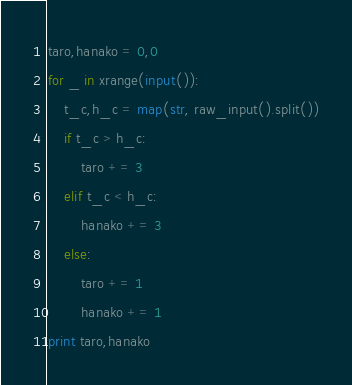Convert code to text. <code><loc_0><loc_0><loc_500><loc_500><_Python_>taro,hanako = 0,0
for _ in xrange(input()):
    t_c,h_c = map(str, raw_input().split())
    if t_c > h_c:
        taro += 3
    elif t_c < h_c:
        hanako += 3
    else:
        taro += 1
        hanako += 1
print taro,hanako</code> 